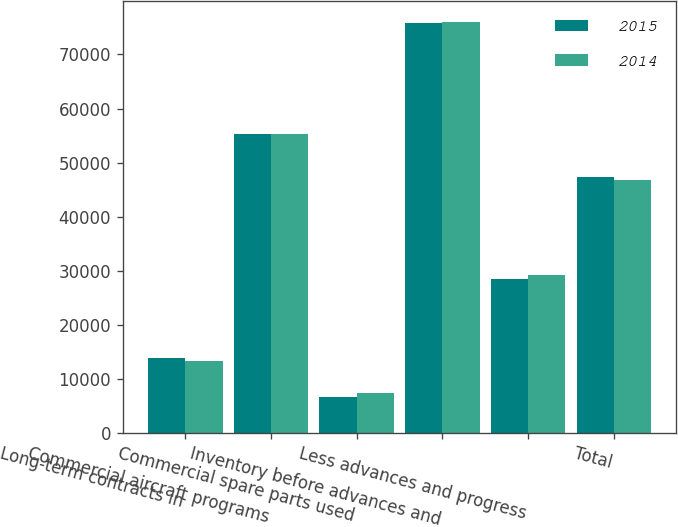Convert chart. <chart><loc_0><loc_0><loc_500><loc_500><stacked_bar_chart><ecel><fcel>Long-term contracts in<fcel>Commercial aircraft programs<fcel>Commercial spare parts used<fcel>Inventory before advances and<fcel>Less advances and progress<fcel>Total<nl><fcel>2015<fcel>13858<fcel>55230<fcel>6673<fcel>75761<fcel>28504<fcel>47257<nl><fcel>2014<fcel>13381<fcel>55220<fcel>7421<fcel>76022<fcel>29266<fcel>46756<nl></chart> 